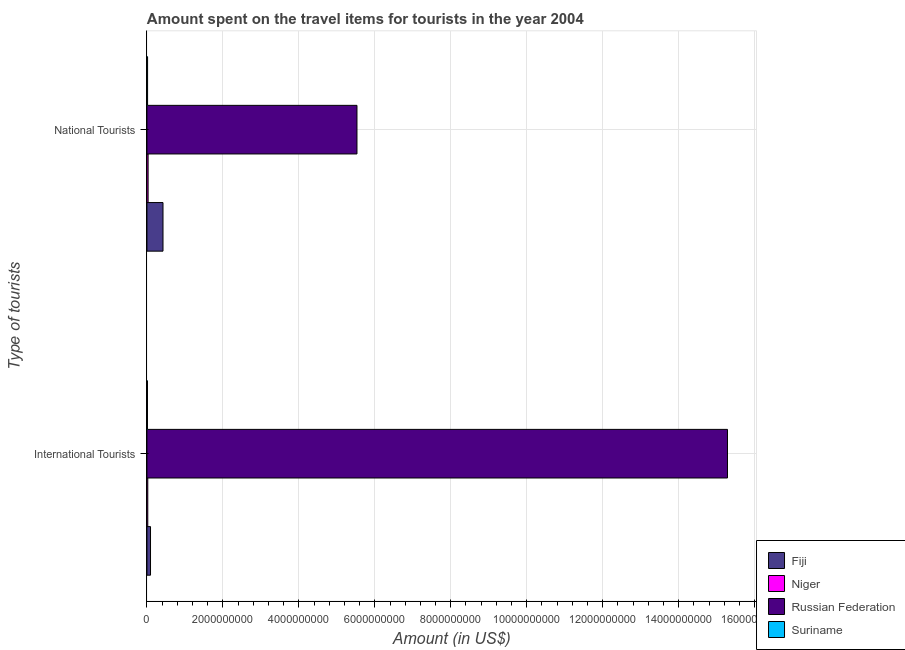How many groups of bars are there?
Offer a very short reply. 2. How many bars are there on the 2nd tick from the bottom?
Your response must be concise. 4. What is the label of the 1st group of bars from the top?
Your answer should be very brief. National Tourists. What is the amount spent on travel items of national tourists in Suriname?
Give a very brief answer. 1.70e+07. Across all countries, what is the maximum amount spent on travel items of national tourists?
Offer a terse response. 5.53e+09. Across all countries, what is the minimum amount spent on travel items of national tourists?
Ensure brevity in your answer.  1.70e+07. In which country was the amount spent on travel items of national tourists maximum?
Provide a succinct answer. Russian Federation. In which country was the amount spent on travel items of national tourists minimum?
Provide a short and direct response. Suriname. What is the total amount spent on travel items of national tourists in the graph?
Ensure brevity in your answer.  6.00e+09. What is the difference between the amount spent on travel items of international tourists in Niger and that in Russian Federation?
Offer a very short reply. -1.53e+1. What is the difference between the amount spent on travel items of international tourists in Niger and the amount spent on travel items of national tourists in Fiji?
Your answer should be compact. -4.01e+08. What is the average amount spent on travel items of international tourists per country?
Your answer should be very brief. 3.85e+09. What is the difference between the amount spent on travel items of national tourists and amount spent on travel items of international tourists in Niger?
Your answer should be compact. 9.00e+06. In how many countries, is the amount spent on travel items of national tourists greater than 15600000000 US$?
Offer a terse response. 0. What is the ratio of the amount spent on travel items of national tourists in Suriname to that in Fiji?
Provide a short and direct response. 0.04. Is the amount spent on travel items of national tourists in Niger less than that in Fiji?
Give a very brief answer. Yes. In how many countries, is the amount spent on travel items of national tourists greater than the average amount spent on travel items of national tourists taken over all countries?
Your answer should be very brief. 1. What does the 1st bar from the top in National Tourists represents?
Your answer should be compact. Suriname. What does the 1st bar from the bottom in National Tourists represents?
Ensure brevity in your answer.  Fiji. What is the difference between two consecutive major ticks on the X-axis?
Offer a very short reply. 2.00e+09. Does the graph contain grids?
Offer a terse response. Yes. Where does the legend appear in the graph?
Provide a short and direct response. Bottom right. What is the title of the graph?
Give a very brief answer. Amount spent on the travel items for tourists in the year 2004. Does "Bosnia and Herzegovina" appear as one of the legend labels in the graph?
Your response must be concise. No. What is the label or title of the Y-axis?
Your answer should be compact. Type of tourists. What is the Amount (in US$) of Fiji in International Tourists?
Your answer should be very brief. 9.40e+07. What is the Amount (in US$) of Niger in International Tourists?
Offer a very short reply. 2.20e+07. What is the Amount (in US$) in Russian Federation in International Tourists?
Offer a terse response. 1.53e+1. What is the Amount (in US$) of Suriname in International Tourists?
Provide a succinct answer. 1.40e+07. What is the Amount (in US$) in Fiji in National Tourists?
Offer a terse response. 4.23e+08. What is the Amount (in US$) of Niger in National Tourists?
Make the answer very short. 3.10e+07. What is the Amount (in US$) in Russian Federation in National Tourists?
Keep it short and to the point. 5.53e+09. What is the Amount (in US$) of Suriname in National Tourists?
Make the answer very short. 1.70e+07. Across all Type of tourists, what is the maximum Amount (in US$) in Fiji?
Your response must be concise. 4.23e+08. Across all Type of tourists, what is the maximum Amount (in US$) of Niger?
Your response must be concise. 3.10e+07. Across all Type of tourists, what is the maximum Amount (in US$) in Russian Federation?
Offer a terse response. 1.53e+1. Across all Type of tourists, what is the maximum Amount (in US$) in Suriname?
Ensure brevity in your answer.  1.70e+07. Across all Type of tourists, what is the minimum Amount (in US$) in Fiji?
Make the answer very short. 9.40e+07. Across all Type of tourists, what is the minimum Amount (in US$) in Niger?
Ensure brevity in your answer.  2.20e+07. Across all Type of tourists, what is the minimum Amount (in US$) of Russian Federation?
Offer a very short reply. 5.53e+09. Across all Type of tourists, what is the minimum Amount (in US$) in Suriname?
Your answer should be compact. 1.40e+07. What is the total Amount (in US$) of Fiji in the graph?
Offer a very short reply. 5.17e+08. What is the total Amount (in US$) of Niger in the graph?
Make the answer very short. 5.30e+07. What is the total Amount (in US$) in Russian Federation in the graph?
Your answer should be compact. 2.08e+1. What is the total Amount (in US$) in Suriname in the graph?
Offer a very short reply. 3.10e+07. What is the difference between the Amount (in US$) in Fiji in International Tourists and that in National Tourists?
Provide a short and direct response. -3.29e+08. What is the difference between the Amount (in US$) of Niger in International Tourists and that in National Tourists?
Make the answer very short. -9.00e+06. What is the difference between the Amount (in US$) in Russian Federation in International Tourists and that in National Tourists?
Provide a short and direct response. 9.76e+09. What is the difference between the Amount (in US$) of Fiji in International Tourists and the Amount (in US$) of Niger in National Tourists?
Your answer should be compact. 6.30e+07. What is the difference between the Amount (in US$) in Fiji in International Tourists and the Amount (in US$) in Russian Federation in National Tourists?
Your answer should be very brief. -5.44e+09. What is the difference between the Amount (in US$) of Fiji in International Tourists and the Amount (in US$) of Suriname in National Tourists?
Make the answer very short. 7.70e+07. What is the difference between the Amount (in US$) in Niger in International Tourists and the Amount (in US$) in Russian Federation in National Tourists?
Offer a very short reply. -5.51e+09. What is the difference between the Amount (in US$) in Russian Federation in International Tourists and the Amount (in US$) in Suriname in National Tourists?
Your answer should be very brief. 1.53e+1. What is the average Amount (in US$) of Fiji per Type of tourists?
Your answer should be very brief. 2.58e+08. What is the average Amount (in US$) in Niger per Type of tourists?
Your answer should be compact. 2.65e+07. What is the average Amount (in US$) of Russian Federation per Type of tourists?
Your answer should be compact. 1.04e+1. What is the average Amount (in US$) of Suriname per Type of tourists?
Your answer should be compact. 1.55e+07. What is the difference between the Amount (in US$) in Fiji and Amount (in US$) in Niger in International Tourists?
Your answer should be very brief. 7.20e+07. What is the difference between the Amount (in US$) of Fiji and Amount (in US$) of Russian Federation in International Tourists?
Offer a very short reply. -1.52e+1. What is the difference between the Amount (in US$) in Fiji and Amount (in US$) in Suriname in International Tourists?
Give a very brief answer. 8.00e+07. What is the difference between the Amount (in US$) in Niger and Amount (in US$) in Russian Federation in International Tourists?
Your answer should be very brief. -1.53e+1. What is the difference between the Amount (in US$) in Niger and Amount (in US$) in Suriname in International Tourists?
Keep it short and to the point. 8.00e+06. What is the difference between the Amount (in US$) of Russian Federation and Amount (in US$) of Suriname in International Tourists?
Provide a short and direct response. 1.53e+1. What is the difference between the Amount (in US$) of Fiji and Amount (in US$) of Niger in National Tourists?
Make the answer very short. 3.92e+08. What is the difference between the Amount (in US$) of Fiji and Amount (in US$) of Russian Federation in National Tourists?
Offer a terse response. -5.11e+09. What is the difference between the Amount (in US$) of Fiji and Amount (in US$) of Suriname in National Tourists?
Your response must be concise. 4.06e+08. What is the difference between the Amount (in US$) in Niger and Amount (in US$) in Russian Federation in National Tourists?
Keep it short and to the point. -5.50e+09. What is the difference between the Amount (in US$) in Niger and Amount (in US$) in Suriname in National Tourists?
Your response must be concise. 1.40e+07. What is the difference between the Amount (in US$) in Russian Federation and Amount (in US$) in Suriname in National Tourists?
Provide a short and direct response. 5.51e+09. What is the ratio of the Amount (in US$) in Fiji in International Tourists to that in National Tourists?
Make the answer very short. 0.22. What is the ratio of the Amount (in US$) in Niger in International Tourists to that in National Tourists?
Keep it short and to the point. 0.71. What is the ratio of the Amount (in US$) of Russian Federation in International Tourists to that in National Tourists?
Offer a very short reply. 2.76. What is the ratio of the Amount (in US$) in Suriname in International Tourists to that in National Tourists?
Provide a short and direct response. 0.82. What is the difference between the highest and the second highest Amount (in US$) in Fiji?
Offer a very short reply. 3.29e+08. What is the difference between the highest and the second highest Amount (in US$) of Niger?
Provide a short and direct response. 9.00e+06. What is the difference between the highest and the second highest Amount (in US$) of Russian Federation?
Provide a succinct answer. 9.76e+09. What is the difference between the highest and the second highest Amount (in US$) in Suriname?
Make the answer very short. 3.00e+06. What is the difference between the highest and the lowest Amount (in US$) of Fiji?
Offer a very short reply. 3.29e+08. What is the difference between the highest and the lowest Amount (in US$) of Niger?
Your answer should be very brief. 9.00e+06. What is the difference between the highest and the lowest Amount (in US$) of Russian Federation?
Offer a terse response. 9.76e+09. What is the difference between the highest and the lowest Amount (in US$) in Suriname?
Provide a succinct answer. 3.00e+06. 